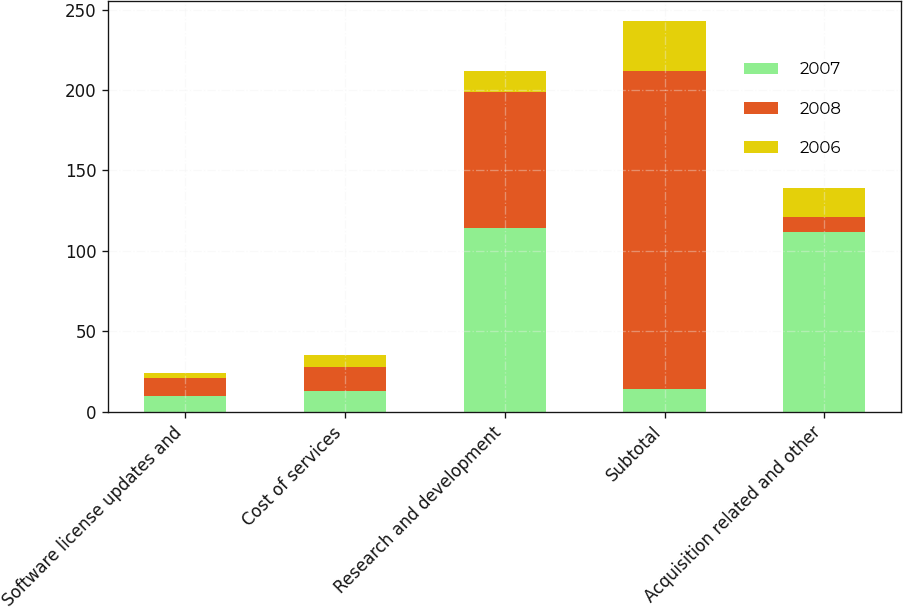Convert chart to OTSL. <chart><loc_0><loc_0><loc_500><loc_500><stacked_bar_chart><ecel><fcel>Software license updates and<fcel>Cost of services<fcel>Research and development<fcel>Subtotal<fcel>Acquisition related and other<nl><fcel>2007<fcel>10<fcel>13<fcel>114<fcel>14<fcel>112<nl><fcel>2008<fcel>11<fcel>15<fcel>85<fcel>198<fcel>9<nl><fcel>2006<fcel>3<fcel>7<fcel>13<fcel>31<fcel>18<nl></chart> 